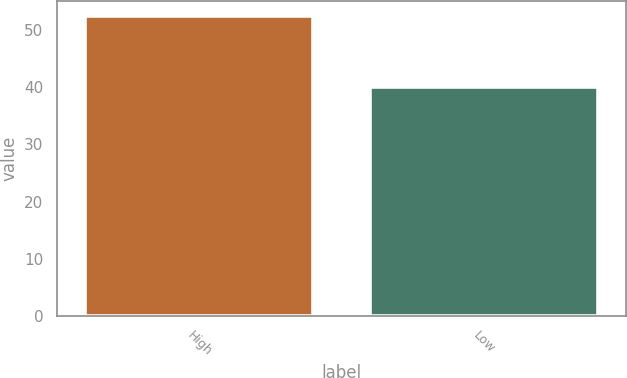<chart> <loc_0><loc_0><loc_500><loc_500><bar_chart><fcel>High<fcel>Low<nl><fcel>52.48<fcel>40.03<nl></chart> 